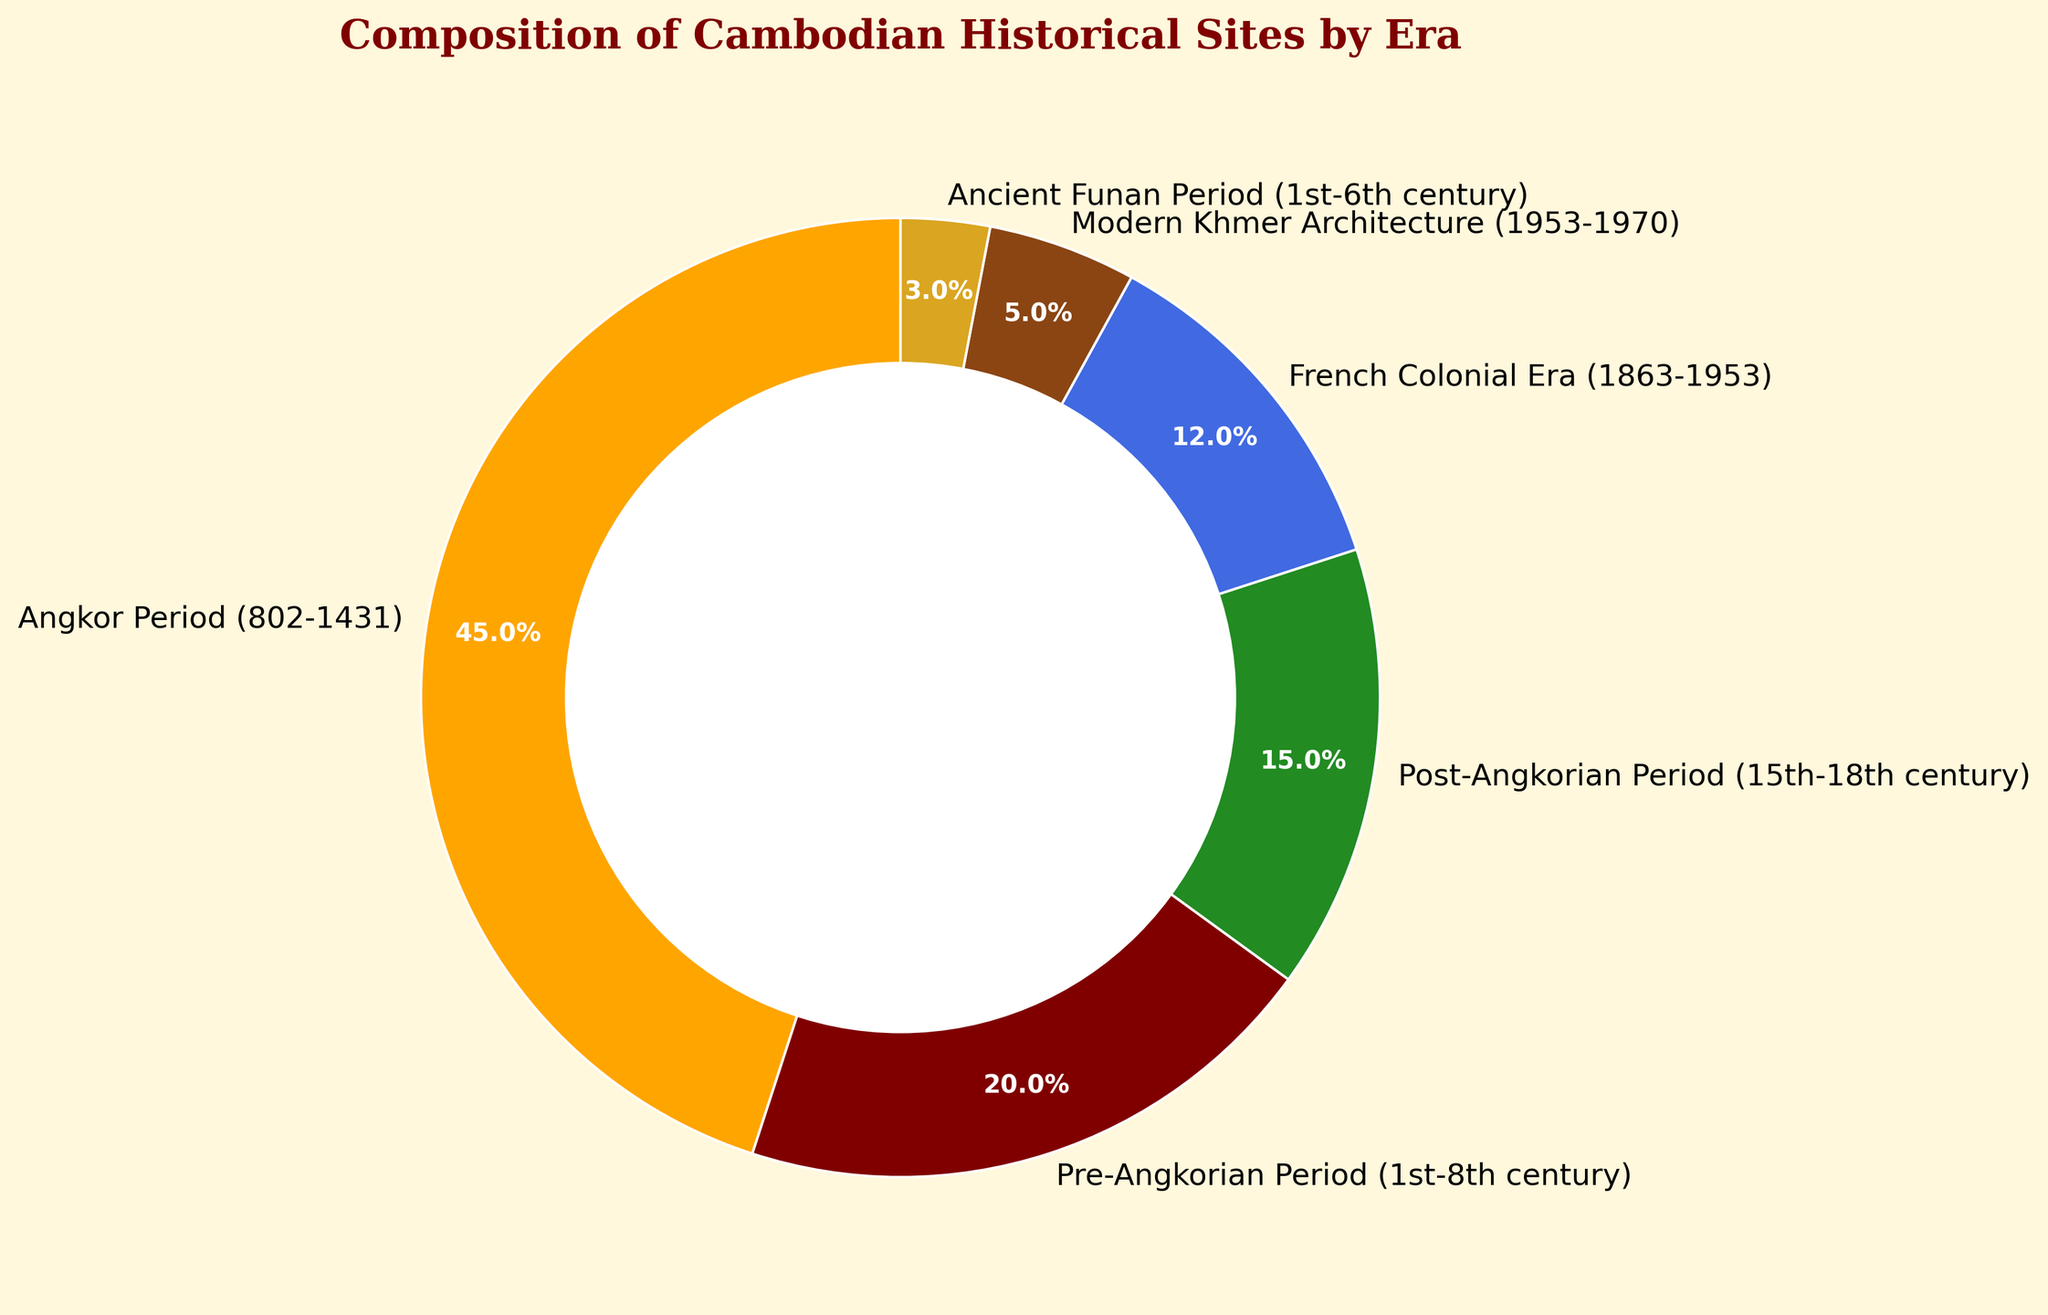Which era has the largest percentage of historical sites? By observing the pie chart, the slice representing the Angkor Period is the largest, taking up more than a third of the chart.
Answer: Angkor Period (802-1431) What is the total percentage of historical sites from the Pre-Angkorian Period and the Post-Angkorian Period? By adding the percentages of the Pre-Angkorian Period (20%) and the Post-Angkorian Period (15%), we get 35%.
Answer: 35% How many times larger is the percentage of historical sites from the Angkor Period compared to the French Colonial Era? By dividing the percentage of the Angkor Period (45%) by that of the French Colonial Era (12%), we find that the Angkor Period is 3.75 times larger.
Answer: 3.75 times Which era has the smallest percentage of historical sites, and what is it? By looking at the proportions of the slices, the smallest slice belongs to the Ancient Funan Period, with a percentage of 3%.
Answer: Ancient Funan Period (3%) Compare the combined percentage of historical sites from the Modern Khmer Architecture and French Colonial Era with that of the Angkor Period. Which is larger? The combined percentage of Modern Khmer Architecture (5%) and the French Colonial Era (12%) is 17%. The Angkor Period alone has 45%, which is clearly larger.
Answer: Angkor Period (45%) Among the eras, which ones have a percentage of historical sites that is less than 10%? By looking at the percentages less than 10%, we find that Modern Khmer Architecture (5%) and Ancient Funan Period (3%) fit this criterion.
Answer: Modern Khmer Architecture, Ancient Funan Period What is the difference in the percentage of historical sites between the Angkor Period and the Post-Angkorian Period? Subtracting the percentage of the Post-Angkorian Period (15%) from that of the Angkor Period (45%) gives us 30%.
Answer: 30% If you add the percentages of the French Colonial Era, Modern Khmer Architecture, and Ancient Funan Period, what is the total? Adding 12% (French Colonial Era), 5% (Modern Khmer Architecture), and 3% (Ancient Funan Period) results in a total of 20%.
Answer: 20% Which color represents the Post-Angkorian Period? By identifying the slice representing the Post-Angkorian Period and its associated color, we see that it is represented by green.
Answer: Green 